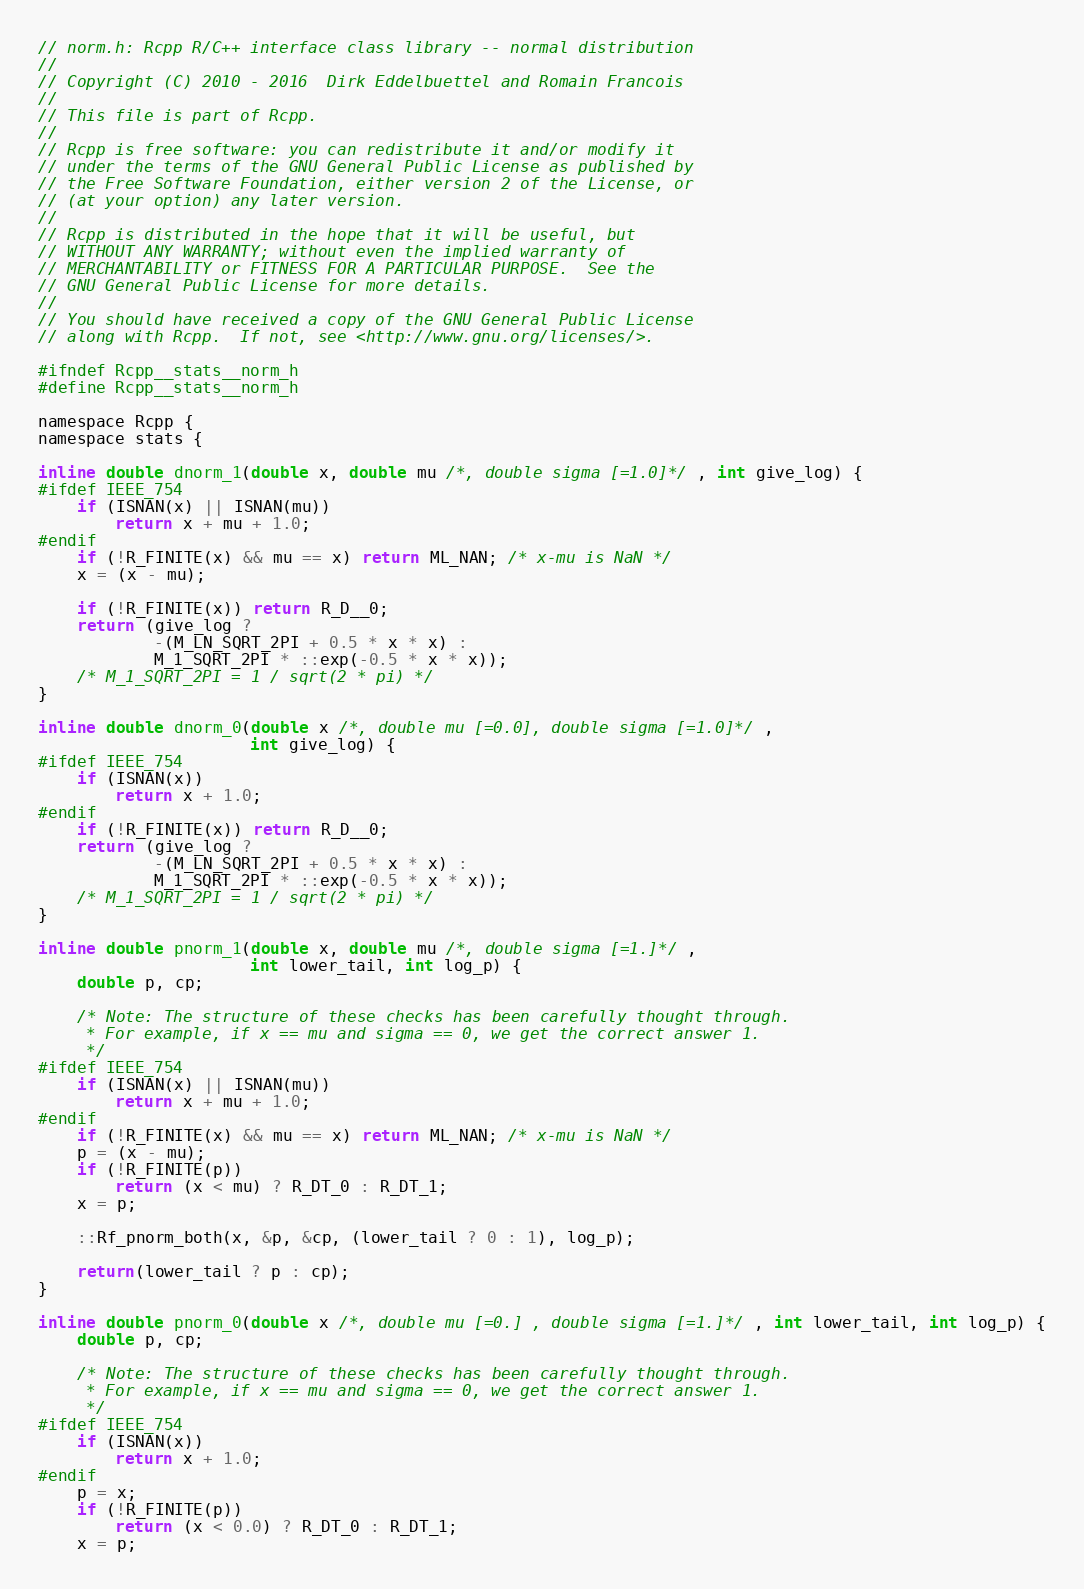Convert code to text. <code><loc_0><loc_0><loc_500><loc_500><_C_>// norm.h: Rcpp R/C++ interface class library -- normal distribution
//
// Copyright (C) 2010 - 2016  Dirk Eddelbuettel and Romain Francois
//
// This file is part of Rcpp.
//
// Rcpp is free software: you can redistribute it and/or modify it
// under the terms of the GNU General Public License as published by
// the Free Software Foundation, either version 2 of the License, or
// (at your option) any later version.
//
// Rcpp is distributed in the hope that it will be useful, but
// WITHOUT ANY WARRANTY; without even the implied warranty of
// MERCHANTABILITY or FITNESS FOR A PARTICULAR PURPOSE.  See the
// GNU General Public License for more details.
//
// You should have received a copy of the GNU General Public License
// along with Rcpp.  If not, see <http://www.gnu.org/licenses/>.

#ifndef Rcpp__stats__norm_h
#define Rcpp__stats__norm_h

namespace Rcpp {
namespace stats {

inline double dnorm_1(double x, double mu /*, double sigma [=1.0]*/ , int give_log) {
#ifdef IEEE_754
    if (ISNAN(x) || ISNAN(mu))
        return x + mu + 1.0;
#endif
    if (!R_FINITE(x) && mu == x) return ML_NAN; /* x-mu is NaN */
    x = (x - mu);

    if (!R_FINITE(x)) return R_D__0;
    return (give_log ?
            -(M_LN_SQRT_2PI + 0.5 * x * x) :
            M_1_SQRT_2PI * ::exp(-0.5 * x * x));
    /* M_1_SQRT_2PI = 1 / sqrt(2 * pi) */
}

inline double dnorm_0(double x /*, double mu [=0.0], double sigma [=1.0]*/ ,
                      int give_log) {
#ifdef IEEE_754
    if (ISNAN(x))
        return x + 1.0;
#endif
    if (!R_FINITE(x)) return R_D__0;
    return (give_log ?
            -(M_LN_SQRT_2PI + 0.5 * x * x) :
            M_1_SQRT_2PI * ::exp(-0.5 * x * x));
    /* M_1_SQRT_2PI = 1 / sqrt(2 * pi) */
}

inline double pnorm_1(double x, double mu /*, double sigma [=1.]*/ ,
                      int lower_tail, int log_p) {
    double p, cp;

    /* Note: The structure of these checks has been carefully thought through.
     * For example, if x == mu and sigma == 0, we get the correct answer 1.
     */
#ifdef IEEE_754
    if (ISNAN(x) || ISNAN(mu))
        return x + mu + 1.0;
#endif
    if (!R_FINITE(x) && mu == x) return ML_NAN; /* x-mu is NaN */
    p = (x - mu);
    if (!R_FINITE(p))
        return (x < mu) ? R_DT_0 : R_DT_1;
    x = p;

    ::Rf_pnorm_both(x, &p, &cp, (lower_tail ? 0 : 1), log_p);

    return(lower_tail ? p : cp);
}

inline double pnorm_0(double x /*, double mu [=0.] , double sigma [=1.]*/ , int lower_tail, int log_p) {
    double p, cp;

    /* Note: The structure of these checks has been carefully thought through.
     * For example, if x == mu and sigma == 0, we get the correct answer 1.
     */
#ifdef IEEE_754
    if (ISNAN(x))
        return x + 1.0;
#endif
    p = x;
    if (!R_FINITE(p))
        return (x < 0.0) ? R_DT_0 : R_DT_1;
    x = p;
</code> 